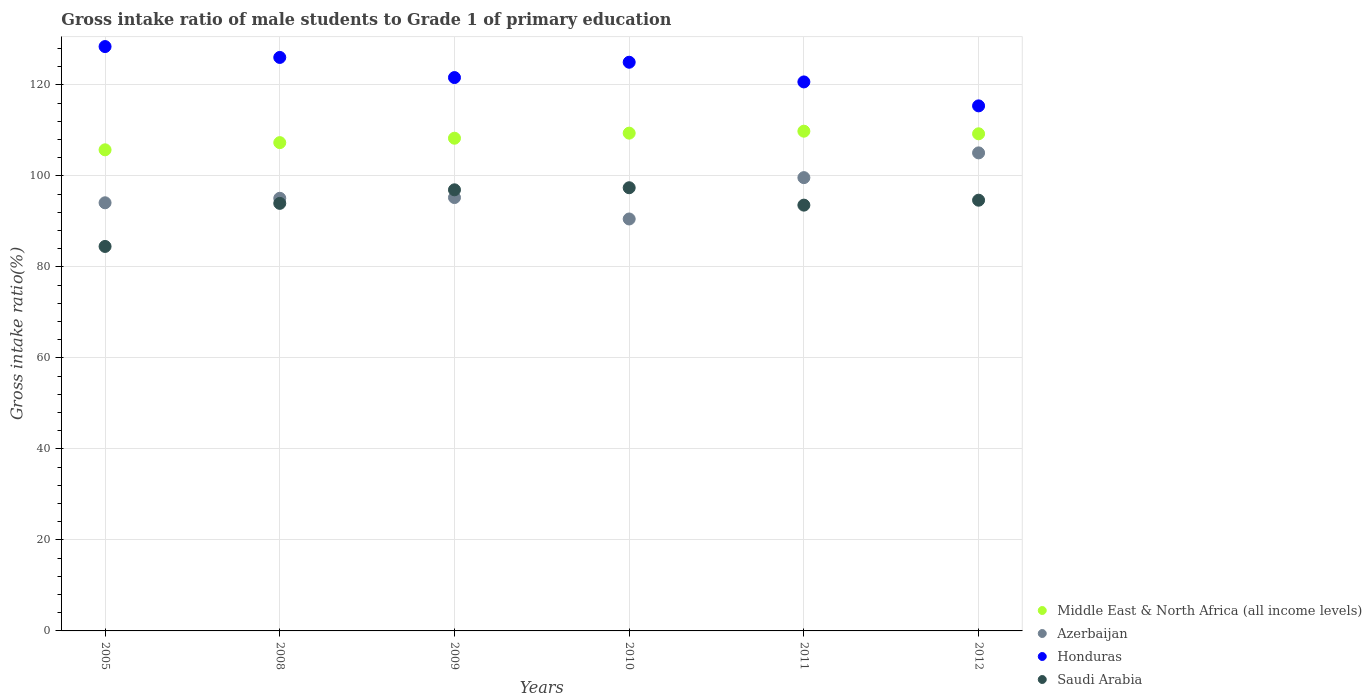What is the gross intake ratio in Middle East & North Africa (all income levels) in 2010?
Ensure brevity in your answer.  109.38. Across all years, what is the maximum gross intake ratio in Saudi Arabia?
Your answer should be compact. 97.39. Across all years, what is the minimum gross intake ratio in Honduras?
Offer a very short reply. 115.37. In which year was the gross intake ratio in Middle East & North Africa (all income levels) maximum?
Your answer should be compact. 2011. What is the total gross intake ratio in Azerbaijan in the graph?
Your answer should be very brief. 579.54. What is the difference between the gross intake ratio in Saudi Arabia in 2009 and that in 2011?
Ensure brevity in your answer.  3.36. What is the difference between the gross intake ratio in Azerbaijan in 2008 and the gross intake ratio in Middle East & North Africa (all income levels) in 2010?
Make the answer very short. -14.31. What is the average gross intake ratio in Honduras per year?
Your response must be concise. 122.83. In the year 2005, what is the difference between the gross intake ratio in Middle East & North Africa (all income levels) and gross intake ratio in Azerbaijan?
Make the answer very short. 11.64. In how many years, is the gross intake ratio in Azerbaijan greater than 40 %?
Make the answer very short. 6. What is the ratio of the gross intake ratio in Azerbaijan in 2008 to that in 2012?
Provide a succinct answer. 0.91. Is the gross intake ratio in Honduras in 2011 less than that in 2012?
Your answer should be compact. No. Is the difference between the gross intake ratio in Middle East & North Africa (all income levels) in 2005 and 2010 greater than the difference between the gross intake ratio in Azerbaijan in 2005 and 2010?
Your answer should be very brief. No. What is the difference between the highest and the second highest gross intake ratio in Honduras?
Offer a very short reply. 2.39. What is the difference between the highest and the lowest gross intake ratio in Honduras?
Provide a succinct answer. 13.03. Is it the case that in every year, the sum of the gross intake ratio in Azerbaijan and gross intake ratio in Honduras  is greater than the gross intake ratio in Saudi Arabia?
Your response must be concise. Yes. How many dotlines are there?
Offer a very short reply. 4. What is the title of the graph?
Keep it short and to the point. Gross intake ratio of male students to Grade 1 of primary education. What is the label or title of the X-axis?
Provide a short and direct response. Years. What is the label or title of the Y-axis?
Your answer should be very brief. Gross intake ratio(%). What is the Gross intake ratio(%) of Middle East & North Africa (all income levels) in 2005?
Keep it short and to the point. 105.72. What is the Gross intake ratio(%) in Azerbaijan in 2005?
Offer a terse response. 94.08. What is the Gross intake ratio(%) of Honduras in 2005?
Your answer should be compact. 128.41. What is the Gross intake ratio(%) of Saudi Arabia in 2005?
Offer a very short reply. 84.49. What is the Gross intake ratio(%) of Middle East & North Africa (all income levels) in 2008?
Offer a very short reply. 107.3. What is the Gross intake ratio(%) of Azerbaijan in 2008?
Provide a succinct answer. 95.07. What is the Gross intake ratio(%) in Honduras in 2008?
Provide a succinct answer. 126.02. What is the Gross intake ratio(%) in Saudi Arabia in 2008?
Your response must be concise. 93.95. What is the Gross intake ratio(%) of Middle East & North Africa (all income levels) in 2009?
Give a very brief answer. 108.27. What is the Gross intake ratio(%) in Azerbaijan in 2009?
Make the answer very short. 95.23. What is the Gross intake ratio(%) of Honduras in 2009?
Give a very brief answer. 121.59. What is the Gross intake ratio(%) of Saudi Arabia in 2009?
Your answer should be compact. 96.93. What is the Gross intake ratio(%) in Middle East & North Africa (all income levels) in 2010?
Offer a very short reply. 109.38. What is the Gross intake ratio(%) in Azerbaijan in 2010?
Ensure brevity in your answer.  90.52. What is the Gross intake ratio(%) in Honduras in 2010?
Ensure brevity in your answer.  124.96. What is the Gross intake ratio(%) in Saudi Arabia in 2010?
Your answer should be very brief. 97.39. What is the Gross intake ratio(%) of Middle East & North Africa (all income levels) in 2011?
Provide a short and direct response. 109.81. What is the Gross intake ratio(%) in Azerbaijan in 2011?
Your response must be concise. 99.61. What is the Gross intake ratio(%) in Honduras in 2011?
Your answer should be compact. 120.64. What is the Gross intake ratio(%) of Saudi Arabia in 2011?
Your answer should be very brief. 93.56. What is the Gross intake ratio(%) in Middle East & North Africa (all income levels) in 2012?
Your answer should be very brief. 109.24. What is the Gross intake ratio(%) of Azerbaijan in 2012?
Provide a short and direct response. 105.04. What is the Gross intake ratio(%) in Honduras in 2012?
Ensure brevity in your answer.  115.37. What is the Gross intake ratio(%) of Saudi Arabia in 2012?
Keep it short and to the point. 94.65. Across all years, what is the maximum Gross intake ratio(%) in Middle East & North Africa (all income levels)?
Your answer should be very brief. 109.81. Across all years, what is the maximum Gross intake ratio(%) in Azerbaijan?
Offer a very short reply. 105.04. Across all years, what is the maximum Gross intake ratio(%) of Honduras?
Ensure brevity in your answer.  128.41. Across all years, what is the maximum Gross intake ratio(%) in Saudi Arabia?
Provide a succinct answer. 97.39. Across all years, what is the minimum Gross intake ratio(%) in Middle East & North Africa (all income levels)?
Your answer should be very brief. 105.72. Across all years, what is the minimum Gross intake ratio(%) in Azerbaijan?
Make the answer very short. 90.52. Across all years, what is the minimum Gross intake ratio(%) in Honduras?
Your answer should be compact. 115.37. Across all years, what is the minimum Gross intake ratio(%) of Saudi Arabia?
Give a very brief answer. 84.49. What is the total Gross intake ratio(%) of Middle East & North Africa (all income levels) in the graph?
Make the answer very short. 649.71. What is the total Gross intake ratio(%) in Azerbaijan in the graph?
Your answer should be very brief. 579.54. What is the total Gross intake ratio(%) in Honduras in the graph?
Give a very brief answer. 736.99. What is the total Gross intake ratio(%) in Saudi Arabia in the graph?
Your answer should be compact. 560.96. What is the difference between the Gross intake ratio(%) of Middle East & North Africa (all income levels) in 2005 and that in 2008?
Give a very brief answer. -1.58. What is the difference between the Gross intake ratio(%) in Azerbaijan in 2005 and that in 2008?
Offer a very short reply. -0.99. What is the difference between the Gross intake ratio(%) in Honduras in 2005 and that in 2008?
Provide a short and direct response. 2.39. What is the difference between the Gross intake ratio(%) in Saudi Arabia in 2005 and that in 2008?
Ensure brevity in your answer.  -9.46. What is the difference between the Gross intake ratio(%) in Middle East & North Africa (all income levels) in 2005 and that in 2009?
Ensure brevity in your answer.  -2.55. What is the difference between the Gross intake ratio(%) in Azerbaijan in 2005 and that in 2009?
Your answer should be compact. -1.15. What is the difference between the Gross intake ratio(%) of Honduras in 2005 and that in 2009?
Make the answer very short. 6.81. What is the difference between the Gross intake ratio(%) in Saudi Arabia in 2005 and that in 2009?
Offer a very short reply. -12.44. What is the difference between the Gross intake ratio(%) of Middle East & North Africa (all income levels) in 2005 and that in 2010?
Your response must be concise. -3.66. What is the difference between the Gross intake ratio(%) of Azerbaijan in 2005 and that in 2010?
Provide a succinct answer. 3.56. What is the difference between the Gross intake ratio(%) in Honduras in 2005 and that in 2010?
Your answer should be compact. 3.44. What is the difference between the Gross intake ratio(%) in Saudi Arabia in 2005 and that in 2010?
Keep it short and to the point. -12.9. What is the difference between the Gross intake ratio(%) in Middle East & North Africa (all income levels) in 2005 and that in 2011?
Keep it short and to the point. -4.09. What is the difference between the Gross intake ratio(%) of Azerbaijan in 2005 and that in 2011?
Your response must be concise. -5.53. What is the difference between the Gross intake ratio(%) in Honduras in 2005 and that in 2011?
Keep it short and to the point. 7.77. What is the difference between the Gross intake ratio(%) in Saudi Arabia in 2005 and that in 2011?
Your answer should be very brief. -9.08. What is the difference between the Gross intake ratio(%) in Middle East & North Africa (all income levels) in 2005 and that in 2012?
Keep it short and to the point. -3.52. What is the difference between the Gross intake ratio(%) in Azerbaijan in 2005 and that in 2012?
Keep it short and to the point. -10.97. What is the difference between the Gross intake ratio(%) of Honduras in 2005 and that in 2012?
Make the answer very short. 13.03. What is the difference between the Gross intake ratio(%) in Saudi Arabia in 2005 and that in 2012?
Offer a terse response. -10.16. What is the difference between the Gross intake ratio(%) in Middle East & North Africa (all income levels) in 2008 and that in 2009?
Offer a terse response. -0.97. What is the difference between the Gross intake ratio(%) in Azerbaijan in 2008 and that in 2009?
Your answer should be compact. -0.16. What is the difference between the Gross intake ratio(%) in Honduras in 2008 and that in 2009?
Ensure brevity in your answer.  4.42. What is the difference between the Gross intake ratio(%) of Saudi Arabia in 2008 and that in 2009?
Your answer should be very brief. -2.98. What is the difference between the Gross intake ratio(%) in Middle East & North Africa (all income levels) in 2008 and that in 2010?
Make the answer very short. -2.08. What is the difference between the Gross intake ratio(%) in Azerbaijan in 2008 and that in 2010?
Your answer should be very brief. 4.55. What is the difference between the Gross intake ratio(%) in Honduras in 2008 and that in 2010?
Ensure brevity in your answer.  1.06. What is the difference between the Gross intake ratio(%) of Saudi Arabia in 2008 and that in 2010?
Keep it short and to the point. -3.44. What is the difference between the Gross intake ratio(%) of Middle East & North Africa (all income levels) in 2008 and that in 2011?
Make the answer very short. -2.51. What is the difference between the Gross intake ratio(%) in Azerbaijan in 2008 and that in 2011?
Keep it short and to the point. -4.54. What is the difference between the Gross intake ratio(%) in Honduras in 2008 and that in 2011?
Make the answer very short. 5.38. What is the difference between the Gross intake ratio(%) in Saudi Arabia in 2008 and that in 2011?
Your answer should be very brief. 0.39. What is the difference between the Gross intake ratio(%) of Middle East & North Africa (all income levels) in 2008 and that in 2012?
Provide a short and direct response. -1.94. What is the difference between the Gross intake ratio(%) in Azerbaijan in 2008 and that in 2012?
Provide a short and direct response. -9.98. What is the difference between the Gross intake ratio(%) of Honduras in 2008 and that in 2012?
Your answer should be very brief. 10.64. What is the difference between the Gross intake ratio(%) in Saudi Arabia in 2008 and that in 2012?
Provide a short and direct response. -0.7. What is the difference between the Gross intake ratio(%) in Middle East & North Africa (all income levels) in 2009 and that in 2010?
Your answer should be compact. -1.11. What is the difference between the Gross intake ratio(%) of Azerbaijan in 2009 and that in 2010?
Your answer should be very brief. 4.71. What is the difference between the Gross intake ratio(%) of Honduras in 2009 and that in 2010?
Keep it short and to the point. -3.37. What is the difference between the Gross intake ratio(%) in Saudi Arabia in 2009 and that in 2010?
Make the answer very short. -0.46. What is the difference between the Gross intake ratio(%) of Middle East & North Africa (all income levels) in 2009 and that in 2011?
Give a very brief answer. -1.54. What is the difference between the Gross intake ratio(%) in Azerbaijan in 2009 and that in 2011?
Provide a succinct answer. -4.38. What is the difference between the Gross intake ratio(%) of Honduras in 2009 and that in 2011?
Ensure brevity in your answer.  0.96. What is the difference between the Gross intake ratio(%) of Saudi Arabia in 2009 and that in 2011?
Give a very brief answer. 3.36. What is the difference between the Gross intake ratio(%) in Middle East & North Africa (all income levels) in 2009 and that in 2012?
Offer a terse response. -0.97. What is the difference between the Gross intake ratio(%) of Azerbaijan in 2009 and that in 2012?
Provide a short and direct response. -9.82. What is the difference between the Gross intake ratio(%) of Honduras in 2009 and that in 2012?
Offer a terse response. 6.22. What is the difference between the Gross intake ratio(%) in Saudi Arabia in 2009 and that in 2012?
Make the answer very short. 2.28. What is the difference between the Gross intake ratio(%) of Middle East & North Africa (all income levels) in 2010 and that in 2011?
Your answer should be compact. -0.43. What is the difference between the Gross intake ratio(%) in Azerbaijan in 2010 and that in 2011?
Provide a succinct answer. -9.09. What is the difference between the Gross intake ratio(%) in Honduras in 2010 and that in 2011?
Your answer should be very brief. 4.32. What is the difference between the Gross intake ratio(%) in Saudi Arabia in 2010 and that in 2011?
Your answer should be compact. 3.82. What is the difference between the Gross intake ratio(%) in Middle East & North Africa (all income levels) in 2010 and that in 2012?
Provide a short and direct response. 0.14. What is the difference between the Gross intake ratio(%) of Azerbaijan in 2010 and that in 2012?
Your answer should be compact. -14.52. What is the difference between the Gross intake ratio(%) in Honduras in 2010 and that in 2012?
Your response must be concise. 9.59. What is the difference between the Gross intake ratio(%) in Saudi Arabia in 2010 and that in 2012?
Provide a short and direct response. 2.74. What is the difference between the Gross intake ratio(%) in Middle East & North Africa (all income levels) in 2011 and that in 2012?
Provide a succinct answer. 0.57. What is the difference between the Gross intake ratio(%) of Azerbaijan in 2011 and that in 2012?
Keep it short and to the point. -5.44. What is the difference between the Gross intake ratio(%) of Honduras in 2011 and that in 2012?
Keep it short and to the point. 5.26. What is the difference between the Gross intake ratio(%) in Saudi Arabia in 2011 and that in 2012?
Make the answer very short. -1.08. What is the difference between the Gross intake ratio(%) in Middle East & North Africa (all income levels) in 2005 and the Gross intake ratio(%) in Azerbaijan in 2008?
Offer a very short reply. 10.65. What is the difference between the Gross intake ratio(%) of Middle East & North Africa (all income levels) in 2005 and the Gross intake ratio(%) of Honduras in 2008?
Offer a very short reply. -20.3. What is the difference between the Gross intake ratio(%) in Middle East & North Africa (all income levels) in 2005 and the Gross intake ratio(%) in Saudi Arabia in 2008?
Your answer should be compact. 11.77. What is the difference between the Gross intake ratio(%) in Azerbaijan in 2005 and the Gross intake ratio(%) in Honduras in 2008?
Your answer should be compact. -31.94. What is the difference between the Gross intake ratio(%) of Azerbaijan in 2005 and the Gross intake ratio(%) of Saudi Arabia in 2008?
Keep it short and to the point. 0.13. What is the difference between the Gross intake ratio(%) in Honduras in 2005 and the Gross intake ratio(%) in Saudi Arabia in 2008?
Provide a succinct answer. 34.46. What is the difference between the Gross intake ratio(%) of Middle East & North Africa (all income levels) in 2005 and the Gross intake ratio(%) of Azerbaijan in 2009?
Provide a succinct answer. 10.49. What is the difference between the Gross intake ratio(%) of Middle East & North Africa (all income levels) in 2005 and the Gross intake ratio(%) of Honduras in 2009?
Your answer should be compact. -15.88. What is the difference between the Gross intake ratio(%) in Middle East & North Africa (all income levels) in 2005 and the Gross intake ratio(%) in Saudi Arabia in 2009?
Make the answer very short. 8.79. What is the difference between the Gross intake ratio(%) in Azerbaijan in 2005 and the Gross intake ratio(%) in Honduras in 2009?
Make the answer very short. -27.52. What is the difference between the Gross intake ratio(%) in Azerbaijan in 2005 and the Gross intake ratio(%) in Saudi Arabia in 2009?
Your answer should be very brief. -2.85. What is the difference between the Gross intake ratio(%) of Honduras in 2005 and the Gross intake ratio(%) of Saudi Arabia in 2009?
Offer a very short reply. 31.48. What is the difference between the Gross intake ratio(%) of Middle East & North Africa (all income levels) in 2005 and the Gross intake ratio(%) of Azerbaijan in 2010?
Keep it short and to the point. 15.2. What is the difference between the Gross intake ratio(%) in Middle East & North Africa (all income levels) in 2005 and the Gross intake ratio(%) in Honduras in 2010?
Keep it short and to the point. -19.24. What is the difference between the Gross intake ratio(%) of Middle East & North Africa (all income levels) in 2005 and the Gross intake ratio(%) of Saudi Arabia in 2010?
Provide a short and direct response. 8.33. What is the difference between the Gross intake ratio(%) in Azerbaijan in 2005 and the Gross intake ratio(%) in Honduras in 2010?
Offer a terse response. -30.88. What is the difference between the Gross intake ratio(%) of Azerbaijan in 2005 and the Gross intake ratio(%) of Saudi Arabia in 2010?
Give a very brief answer. -3.31. What is the difference between the Gross intake ratio(%) of Honduras in 2005 and the Gross intake ratio(%) of Saudi Arabia in 2010?
Your answer should be compact. 31.02. What is the difference between the Gross intake ratio(%) in Middle East & North Africa (all income levels) in 2005 and the Gross intake ratio(%) in Azerbaijan in 2011?
Your response must be concise. 6.11. What is the difference between the Gross intake ratio(%) of Middle East & North Africa (all income levels) in 2005 and the Gross intake ratio(%) of Honduras in 2011?
Ensure brevity in your answer.  -14.92. What is the difference between the Gross intake ratio(%) of Middle East & North Africa (all income levels) in 2005 and the Gross intake ratio(%) of Saudi Arabia in 2011?
Offer a very short reply. 12.15. What is the difference between the Gross intake ratio(%) in Azerbaijan in 2005 and the Gross intake ratio(%) in Honduras in 2011?
Offer a terse response. -26.56. What is the difference between the Gross intake ratio(%) in Azerbaijan in 2005 and the Gross intake ratio(%) in Saudi Arabia in 2011?
Your answer should be compact. 0.51. What is the difference between the Gross intake ratio(%) of Honduras in 2005 and the Gross intake ratio(%) of Saudi Arabia in 2011?
Make the answer very short. 34.84. What is the difference between the Gross intake ratio(%) in Middle East & North Africa (all income levels) in 2005 and the Gross intake ratio(%) in Azerbaijan in 2012?
Provide a short and direct response. 0.67. What is the difference between the Gross intake ratio(%) in Middle East & North Africa (all income levels) in 2005 and the Gross intake ratio(%) in Honduras in 2012?
Make the answer very short. -9.66. What is the difference between the Gross intake ratio(%) in Middle East & North Africa (all income levels) in 2005 and the Gross intake ratio(%) in Saudi Arabia in 2012?
Your response must be concise. 11.07. What is the difference between the Gross intake ratio(%) of Azerbaijan in 2005 and the Gross intake ratio(%) of Honduras in 2012?
Your answer should be compact. -21.3. What is the difference between the Gross intake ratio(%) in Azerbaijan in 2005 and the Gross intake ratio(%) in Saudi Arabia in 2012?
Your answer should be very brief. -0.57. What is the difference between the Gross intake ratio(%) of Honduras in 2005 and the Gross intake ratio(%) of Saudi Arabia in 2012?
Provide a short and direct response. 33.76. What is the difference between the Gross intake ratio(%) in Middle East & North Africa (all income levels) in 2008 and the Gross intake ratio(%) in Azerbaijan in 2009?
Your answer should be very brief. 12.07. What is the difference between the Gross intake ratio(%) in Middle East & North Africa (all income levels) in 2008 and the Gross intake ratio(%) in Honduras in 2009?
Ensure brevity in your answer.  -14.3. What is the difference between the Gross intake ratio(%) of Middle East & North Africa (all income levels) in 2008 and the Gross intake ratio(%) of Saudi Arabia in 2009?
Keep it short and to the point. 10.37. What is the difference between the Gross intake ratio(%) of Azerbaijan in 2008 and the Gross intake ratio(%) of Honduras in 2009?
Offer a very short reply. -26.53. What is the difference between the Gross intake ratio(%) in Azerbaijan in 2008 and the Gross intake ratio(%) in Saudi Arabia in 2009?
Your response must be concise. -1.86. What is the difference between the Gross intake ratio(%) of Honduras in 2008 and the Gross intake ratio(%) of Saudi Arabia in 2009?
Your answer should be very brief. 29.09. What is the difference between the Gross intake ratio(%) in Middle East & North Africa (all income levels) in 2008 and the Gross intake ratio(%) in Azerbaijan in 2010?
Make the answer very short. 16.78. What is the difference between the Gross intake ratio(%) in Middle East & North Africa (all income levels) in 2008 and the Gross intake ratio(%) in Honduras in 2010?
Your response must be concise. -17.66. What is the difference between the Gross intake ratio(%) in Middle East & North Africa (all income levels) in 2008 and the Gross intake ratio(%) in Saudi Arabia in 2010?
Give a very brief answer. 9.91. What is the difference between the Gross intake ratio(%) in Azerbaijan in 2008 and the Gross intake ratio(%) in Honduras in 2010?
Make the answer very short. -29.89. What is the difference between the Gross intake ratio(%) in Azerbaijan in 2008 and the Gross intake ratio(%) in Saudi Arabia in 2010?
Ensure brevity in your answer.  -2.32. What is the difference between the Gross intake ratio(%) in Honduras in 2008 and the Gross intake ratio(%) in Saudi Arabia in 2010?
Give a very brief answer. 28.63. What is the difference between the Gross intake ratio(%) of Middle East & North Africa (all income levels) in 2008 and the Gross intake ratio(%) of Azerbaijan in 2011?
Ensure brevity in your answer.  7.69. What is the difference between the Gross intake ratio(%) of Middle East & North Africa (all income levels) in 2008 and the Gross intake ratio(%) of Honduras in 2011?
Your response must be concise. -13.34. What is the difference between the Gross intake ratio(%) of Middle East & North Africa (all income levels) in 2008 and the Gross intake ratio(%) of Saudi Arabia in 2011?
Your response must be concise. 13.73. What is the difference between the Gross intake ratio(%) in Azerbaijan in 2008 and the Gross intake ratio(%) in Honduras in 2011?
Give a very brief answer. -25.57. What is the difference between the Gross intake ratio(%) in Azerbaijan in 2008 and the Gross intake ratio(%) in Saudi Arabia in 2011?
Keep it short and to the point. 1.5. What is the difference between the Gross intake ratio(%) in Honduras in 2008 and the Gross intake ratio(%) in Saudi Arabia in 2011?
Offer a very short reply. 32.45. What is the difference between the Gross intake ratio(%) of Middle East & North Africa (all income levels) in 2008 and the Gross intake ratio(%) of Azerbaijan in 2012?
Offer a terse response. 2.25. What is the difference between the Gross intake ratio(%) of Middle East & North Africa (all income levels) in 2008 and the Gross intake ratio(%) of Honduras in 2012?
Your answer should be very brief. -8.08. What is the difference between the Gross intake ratio(%) in Middle East & North Africa (all income levels) in 2008 and the Gross intake ratio(%) in Saudi Arabia in 2012?
Keep it short and to the point. 12.65. What is the difference between the Gross intake ratio(%) of Azerbaijan in 2008 and the Gross intake ratio(%) of Honduras in 2012?
Your answer should be very brief. -20.31. What is the difference between the Gross intake ratio(%) in Azerbaijan in 2008 and the Gross intake ratio(%) in Saudi Arabia in 2012?
Make the answer very short. 0.42. What is the difference between the Gross intake ratio(%) of Honduras in 2008 and the Gross intake ratio(%) of Saudi Arabia in 2012?
Provide a short and direct response. 31.37. What is the difference between the Gross intake ratio(%) in Middle East & North Africa (all income levels) in 2009 and the Gross intake ratio(%) in Azerbaijan in 2010?
Keep it short and to the point. 17.75. What is the difference between the Gross intake ratio(%) in Middle East & North Africa (all income levels) in 2009 and the Gross intake ratio(%) in Honduras in 2010?
Make the answer very short. -16.69. What is the difference between the Gross intake ratio(%) in Middle East & North Africa (all income levels) in 2009 and the Gross intake ratio(%) in Saudi Arabia in 2010?
Provide a short and direct response. 10.88. What is the difference between the Gross intake ratio(%) of Azerbaijan in 2009 and the Gross intake ratio(%) of Honduras in 2010?
Offer a very short reply. -29.73. What is the difference between the Gross intake ratio(%) in Azerbaijan in 2009 and the Gross intake ratio(%) in Saudi Arabia in 2010?
Your answer should be very brief. -2.16. What is the difference between the Gross intake ratio(%) in Honduras in 2009 and the Gross intake ratio(%) in Saudi Arabia in 2010?
Offer a terse response. 24.21. What is the difference between the Gross intake ratio(%) in Middle East & North Africa (all income levels) in 2009 and the Gross intake ratio(%) in Azerbaijan in 2011?
Your response must be concise. 8.66. What is the difference between the Gross intake ratio(%) in Middle East & North Africa (all income levels) in 2009 and the Gross intake ratio(%) in Honduras in 2011?
Provide a succinct answer. -12.37. What is the difference between the Gross intake ratio(%) in Middle East & North Africa (all income levels) in 2009 and the Gross intake ratio(%) in Saudi Arabia in 2011?
Your answer should be very brief. 14.7. What is the difference between the Gross intake ratio(%) in Azerbaijan in 2009 and the Gross intake ratio(%) in Honduras in 2011?
Your answer should be compact. -25.41. What is the difference between the Gross intake ratio(%) of Azerbaijan in 2009 and the Gross intake ratio(%) of Saudi Arabia in 2011?
Provide a succinct answer. 1.67. What is the difference between the Gross intake ratio(%) in Honduras in 2009 and the Gross intake ratio(%) in Saudi Arabia in 2011?
Provide a succinct answer. 28.03. What is the difference between the Gross intake ratio(%) in Middle East & North Africa (all income levels) in 2009 and the Gross intake ratio(%) in Azerbaijan in 2012?
Provide a short and direct response. 3.22. What is the difference between the Gross intake ratio(%) in Middle East & North Africa (all income levels) in 2009 and the Gross intake ratio(%) in Honduras in 2012?
Offer a terse response. -7.11. What is the difference between the Gross intake ratio(%) in Middle East & North Africa (all income levels) in 2009 and the Gross intake ratio(%) in Saudi Arabia in 2012?
Offer a very short reply. 13.62. What is the difference between the Gross intake ratio(%) in Azerbaijan in 2009 and the Gross intake ratio(%) in Honduras in 2012?
Your answer should be very brief. -20.14. What is the difference between the Gross intake ratio(%) of Azerbaijan in 2009 and the Gross intake ratio(%) of Saudi Arabia in 2012?
Keep it short and to the point. 0.58. What is the difference between the Gross intake ratio(%) in Honduras in 2009 and the Gross intake ratio(%) in Saudi Arabia in 2012?
Provide a short and direct response. 26.95. What is the difference between the Gross intake ratio(%) of Middle East & North Africa (all income levels) in 2010 and the Gross intake ratio(%) of Azerbaijan in 2011?
Offer a very short reply. 9.77. What is the difference between the Gross intake ratio(%) in Middle East & North Africa (all income levels) in 2010 and the Gross intake ratio(%) in Honduras in 2011?
Your answer should be very brief. -11.26. What is the difference between the Gross intake ratio(%) in Middle East & North Africa (all income levels) in 2010 and the Gross intake ratio(%) in Saudi Arabia in 2011?
Make the answer very short. 15.82. What is the difference between the Gross intake ratio(%) of Azerbaijan in 2010 and the Gross intake ratio(%) of Honduras in 2011?
Offer a very short reply. -30.12. What is the difference between the Gross intake ratio(%) of Azerbaijan in 2010 and the Gross intake ratio(%) of Saudi Arabia in 2011?
Give a very brief answer. -3.04. What is the difference between the Gross intake ratio(%) of Honduras in 2010 and the Gross intake ratio(%) of Saudi Arabia in 2011?
Your response must be concise. 31.4. What is the difference between the Gross intake ratio(%) in Middle East & North Africa (all income levels) in 2010 and the Gross intake ratio(%) in Azerbaijan in 2012?
Your answer should be very brief. 4.34. What is the difference between the Gross intake ratio(%) of Middle East & North Africa (all income levels) in 2010 and the Gross intake ratio(%) of Honduras in 2012?
Offer a terse response. -5.99. What is the difference between the Gross intake ratio(%) in Middle East & North Africa (all income levels) in 2010 and the Gross intake ratio(%) in Saudi Arabia in 2012?
Give a very brief answer. 14.73. What is the difference between the Gross intake ratio(%) in Azerbaijan in 2010 and the Gross intake ratio(%) in Honduras in 2012?
Your answer should be very brief. -24.85. What is the difference between the Gross intake ratio(%) of Azerbaijan in 2010 and the Gross intake ratio(%) of Saudi Arabia in 2012?
Give a very brief answer. -4.13. What is the difference between the Gross intake ratio(%) of Honduras in 2010 and the Gross intake ratio(%) of Saudi Arabia in 2012?
Offer a terse response. 30.31. What is the difference between the Gross intake ratio(%) of Middle East & North Africa (all income levels) in 2011 and the Gross intake ratio(%) of Azerbaijan in 2012?
Your answer should be compact. 4.77. What is the difference between the Gross intake ratio(%) of Middle East & North Africa (all income levels) in 2011 and the Gross intake ratio(%) of Honduras in 2012?
Keep it short and to the point. -5.56. What is the difference between the Gross intake ratio(%) in Middle East & North Africa (all income levels) in 2011 and the Gross intake ratio(%) in Saudi Arabia in 2012?
Offer a terse response. 15.16. What is the difference between the Gross intake ratio(%) in Azerbaijan in 2011 and the Gross intake ratio(%) in Honduras in 2012?
Keep it short and to the point. -15.77. What is the difference between the Gross intake ratio(%) in Azerbaijan in 2011 and the Gross intake ratio(%) in Saudi Arabia in 2012?
Your answer should be very brief. 4.96. What is the difference between the Gross intake ratio(%) of Honduras in 2011 and the Gross intake ratio(%) of Saudi Arabia in 2012?
Give a very brief answer. 25.99. What is the average Gross intake ratio(%) of Middle East & North Africa (all income levels) per year?
Your answer should be very brief. 108.29. What is the average Gross intake ratio(%) of Azerbaijan per year?
Make the answer very short. 96.59. What is the average Gross intake ratio(%) of Honduras per year?
Give a very brief answer. 122.83. What is the average Gross intake ratio(%) in Saudi Arabia per year?
Ensure brevity in your answer.  93.49. In the year 2005, what is the difference between the Gross intake ratio(%) in Middle East & North Africa (all income levels) and Gross intake ratio(%) in Azerbaijan?
Make the answer very short. 11.64. In the year 2005, what is the difference between the Gross intake ratio(%) of Middle East & North Africa (all income levels) and Gross intake ratio(%) of Honduras?
Provide a short and direct response. -22.69. In the year 2005, what is the difference between the Gross intake ratio(%) in Middle East & North Africa (all income levels) and Gross intake ratio(%) in Saudi Arabia?
Ensure brevity in your answer.  21.23. In the year 2005, what is the difference between the Gross intake ratio(%) of Azerbaijan and Gross intake ratio(%) of Honduras?
Keep it short and to the point. -34.33. In the year 2005, what is the difference between the Gross intake ratio(%) of Azerbaijan and Gross intake ratio(%) of Saudi Arabia?
Offer a very short reply. 9.59. In the year 2005, what is the difference between the Gross intake ratio(%) in Honduras and Gross intake ratio(%) in Saudi Arabia?
Ensure brevity in your answer.  43.92. In the year 2008, what is the difference between the Gross intake ratio(%) in Middle East & North Africa (all income levels) and Gross intake ratio(%) in Azerbaijan?
Make the answer very short. 12.23. In the year 2008, what is the difference between the Gross intake ratio(%) in Middle East & North Africa (all income levels) and Gross intake ratio(%) in Honduras?
Keep it short and to the point. -18.72. In the year 2008, what is the difference between the Gross intake ratio(%) of Middle East & North Africa (all income levels) and Gross intake ratio(%) of Saudi Arabia?
Your response must be concise. 13.35. In the year 2008, what is the difference between the Gross intake ratio(%) in Azerbaijan and Gross intake ratio(%) in Honduras?
Ensure brevity in your answer.  -30.95. In the year 2008, what is the difference between the Gross intake ratio(%) of Azerbaijan and Gross intake ratio(%) of Saudi Arabia?
Make the answer very short. 1.12. In the year 2008, what is the difference between the Gross intake ratio(%) in Honduras and Gross intake ratio(%) in Saudi Arabia?
Your answer should be very brief. 32.07. In the year 2009, what is the difference between the Gross intake ratio(%) in Middle East & North Africa (all income levels) and Gross intake ratio(%) in Azerbaijan?
Offer a terse response. 13.04. In the year 2009, what is the difference between the Gross intake ratio(%) in Middle East & North Africa (all income levels) and Gross intake ratio(%) in Honduras?
Provide a short and direct response. -13.33. In the year 2009, what is the difference between the Gross intake ratio(%) of Middle East & North Africa (all income levels) and Gross intake ratio(%) of Saudi Arabia?
Your answer should be compact. 11.34. In the year 2009, what is the difference between the Gross intake ratio(%) of Azerbaijan and Gross intake ratio(%) of Honduras?
Offer a terse response. -26.36. In the year 2009, what is the difference between the Gross intake ratio(%) of Azerbaijan and Gross intake ratio(%) of Saudi Arabia?
Provide a succinct answer. -1.7. In the year 2009, what is the difference between the Gross intake ratio(%) of Honduras and Gross intake ratio(%) of Saudi Arabia?
Give a very brief answer. 24.67. In the year 2010, what is the difference between the Gross intake ratio(%) of Middle East & North Africa (all income levels) and Gross intake ratio(%) of Azerbaijan?
Provide a succinct answer. 18.86. In the year 2010, what is the difference between the Gross intake ratio(%) of Middle East & North Africa (all income levels) and Gross intake ratio(%) of Honduras?
Offer a very short reply. -15.58. In the year 2010, what is the difference between the Gross intake ratio(%) of Middle East & North Africa (all income levels) and Gross intake ratio(%) of Saudi Arabia?
Make the answer very short. 11.99. In the year 2010, what is the difference between the Gross intake ratio(%) in Azerbaijan and Gross intake ratio(%) in Honduras?
Keep it short and to the point. -34.44. In the year 2010, what is the difference between the Gross intake ratio(%) of Azerbaijan and Gross intake ratio(%) of Saudi Arabia?
Make the answer very short. -6.87. In the year 2010, what is the difference between the Gross intake ratio(%) in Honduras and Gross intake ratio(%) in Saudi Arabia?
Your response must be concise. 27.58. In the year 2011, what is the difference between the Gross intake ratio(%) in Middle East & North Africa (all income levels) and Gross intake ratio(%) in Azerbaijan?
Ensure brevity in your answer.  10.21. In the year 2011, what is the difference between the Gross intake ratio(%) of Middle East & North Africa (all income levels) and Gross intake ratio(%) of Honduras?
Provide a succinct answer. -10.83. In the year 2011, what is the difference between the Gross intake ratio(%) of Middle East & North Africa (all income levels) and Gross intake ratio(%) of Saudi Arabia?
Keep it short and to the point. 16.25. In the year 2011, what is the difference between the Gross intake ratio(%) in Azerbaijan and Gross intake ratio(%) in Honduras?
Give a very brief answer. -21.03. In the year 2011, what is the difference between the Gross intake ratio(%) of Azerbaijan and Gross intake ratio(%) of Saudi Arabia?
Offer a very short reply. 6.04. In the year 2011, what is the difference between the Gross intake ratio(%) in Honduras and Gross intake ratio(%) in Saudi Arabia?
Provide a succinct answer. 27.07. In the year 2012, what is the difference between the Gross intake ratio(%) in Middle East & North Africa (all income levels) and Gross intake ratio(%) in Azerbaijan?
Your response must be concise. 4.2. In the year 2012, what is the difference between the Gross intake ratio(%) in Middle East & North Africa (all income levels) and Gross intake ratio(%) in Honduras?
Your response must be concise. -6.13. In the year 2012, what is the difference between the Gross intake ratio(%) in Middle East & North Africa (all income levels) and Gross intake ratio(%) in Saudi Arabia?
Your response must be concise. 14.59. In the year 2012, what is the difference between the Gross intake ratio(%) in Azerbaijan and Gross intake ratio(%) in Honduras?
Your answer should be compact. -10.33. In the year 2012, what is the difference between the Gross intake ratio(%) in Azerbaijan and Gross intake ratio(%) in Saudi Arabia?
Provide a short and direct response. 10.4. In the year 2012, what is the difference between the Gross intake ratio(%) in Honduras and Gross intake ratio(%) in Saudi Arabia?
Your answer should be compact. 20.73. What is the ratio of the Gross intake ratio(%) of Honduras in 2005 to that in 2008?
Keep it short and to the point. 1.02. What is the ratio of the Gross intake ratio(%) of Saudi Arabia in 2005 to that in 2008?
Make the answer very short. 0.9. What is the ratio of the Gross intake ratio(%) in Middle East & North Africa (all income levels) in 2005 to that in 2009?
Give a very brief answer. 0.98. What is the ratio of the Gross intake ratio(%) in Azerbaijan in 2005 to that in 2009?
Provide a short and direct response. 0.99. What is the ratio of the Gross intake ratio(%) of Honduras in 2005 to that in 2009?
Provide a short and direct response. 1.06. What is the ratio of the Gross intake ratio(%) of Saudi Arabia in 2005 to that in 2009?
Your response must be concise. 0.87. What is the ratio of the Gross intake ratio(%) in Middle East & North Africa (all income levels) in 2005 to that in 2010?
Provide a short and direct response. 0.97. What is the ratio of the Gross intake ratio(%) in Azerbaijan in 2005 to that in 2010?
Give a very brief answer. 1.04. What is the ratio of the Gross intake ratio(%) in Honduras in 2005 to that in 2010?
Provide a short and direct response. 1.03. What is the ratio of the Gross intake ratio(%) of Saudi Arabia in 2005 to that in 2010?
Ensure brevity in your answer.  0.87. What is the ratio of the Gross intake ratio(%) in Middle East & North Africa (all income levels) in 2005 to that in 2011?
Keep it short and to the point. 0.96. What is the ratio of the Gross intake ratio(%) in Azerbaijan in 2005 to that in 2011?
Keep it short and to the point. 0.94. What is the ratio of the Gross intake ratio(%) of Honduras in 2005 to that in 2011?
Offer a very short reply. 1.06. What is the ratio of the Gross intake ratio(%) of Saudi Arabia in 2005 to that in 2011?
Give a very brief answer. 0.9. What is the ratio of the Gross intake ratio(%) in Middle East & North Africa (all income levels) in 2005 to that in 2012?
Give a very brief answer. 0.97. What is the ratio of the Gross intake ratio(%) in Azerbaijan in 2005 to that in 2012?
Your response must be concise. 0.9. What is the ratio of the Gross intake ratio(%) in Honduras in 2005 to that in 2012?
Ensure brevity in your answer.  1.11. What is the ratio of the Gross intake ratio(%) of Saudi Arabia in 2005 to that in 2012?
Offer a terse response. 0.89. What is the ratio of the Gross intake ratio(%) in Azerbaijan in 2008 to that in 2009?
Offer a terse response. 1. What is the ratio of the Gross intake ratio(%) of Honduras in 2008 to that in 2009?
Make the answer very short. 1.04. What is the ratio of the Gross intake ratio(%) of Saudi Arabia in 2008 to that in 2009?
Your answer should be compact. 0.97. What is the ratio of the Gross intake ratio(%) in Middle East & North Africa (all income levels) in 2008 to that in 2010?
Offer a very short reply. 0.98. What is the ratio of the Gross intake ratio(%) of Azerbaijan in 2008 to that in 2010?
Offer a terse response. 1.05. What is the ratio of the Gross intake ratio(%) of Honduras in 2008 to that in 2010?
Make the answer very short. 1.01. What is the ratio of the Gross intake ratio(%) in Saudi Arabia in 2008 to that in 2010?
Give a very brief answer. 0.96. What is the ratio of the Gross intake ratio(%) in Middle East & North Africa (all income levels) in 2008 to that in 2011?
Make the answer very short. 0.98. What is the ratio of the Gross intake ratio(%) in Azerbaijan in 2008 to that in 2011?
Your answer should be compact. 0.95. What is the ratio of the Gross intake ratio(%) of Honduras in 2008 to that in 2011?
Offer a terse response. 1.04. What is the ratio of the Gross intake ratio(%) in Saudi Arabia in 2008 to that in 2011?
Ensure brevity in your answer.  1. What is the ratio of the Gross intake ratio(%) of Middle East & North Africa (all income levels) in 2008 to that in 2012?
Offer a terse response. 0.98. What is the ratio of the Gross intake ratio(%) of Azerbaijan in 2008 to that in 2012?
Provide a short and direct response. 0.91. What is the ratio of the Gross intake ratio(%) in Honduras in 2008 to that in 2012?
Offer a very short reply. 1.09. What is the ratio of the Gross intake ratio(%) in Saudi Arabia in 2008 to that in 2012?
Your answer should be very brief. 0.99. What is the ratio of the Gross intake ratio(%) in Middle East & North Africa (all income levels) in 2009 to that in 2010?
Your response must be concise. 0.99. What is the ratio of the Gross intake ratio(%) of Azerbaijan in 2009 to that in 2010?
Your answer should be compact. 1.05. What is the ratio of the Gross intake ratio(%) in Honduras in 2009 to that in 2010?
Provide a short and direct response. 0.97. What is the ratio of the Gross intake ratio(%) of Middle East & North Africa (all income levels) in 2009 to that in 2011?
Offer a terse response. 0.99. What is the ratio of the Gross intake ratio(%) in Azerbaijan in 2009 to that in 2011?
Provide a short and direct response. 0.96. What is the ratio of the Gross intake ratio(%) in Honduras in 2009 to that in 2011?
Keep it short and to the point. 1.01. What is the ratio of the Gross intake ratio(%) in Saudi Arabia in 2009 to that in 2011?
Make the answer very short. 1.04. What is the ratio of the Gross intake ratio(%) of Azerbaijan in 2009 to that in 2012?
Offer a very short reply. 0.91. What is the ratio of the Gross intake ratio(%) in Honduras in 2009 to that in 2012?
Your answer should be compact. 1.05. What is the ratio of the Gross intake ratio(%) of Saudi Arabia in 2009 to that in 2012?
Give a very brief answer. 1.02. What is the ratio of the Gross intake ratio(%) of Middle East & North Africa (all income levels) in 2010 to that in 2011?
Provide a succinct answer. 1. What is the ratio of the Gross intake ratio(%) in Azerbaijan in 2010 to that in 2011?
Your response must be concise. 0.91. What is the ratio of the Gross intake ratio(%) of Honduras in 2010 to that in 2011?
Your answer should be very brief. 1.04. What is the ratio of the Gross intake ratio(%) of Saudi Arabia in 2010 to that in 2011?
Provide a short and direct response. 1.04. What is the ratio of the Gross intake ratio(%) in Azerbaijan in 2010 to that in 2012?
Provide a succinct answer. 0.86. What is the ratio of the Gross intake ratio(%) in Honduras in 2010 to that in 2012?
Provide a succinct answer. 1.08. What is the ratio of the Gross intake ratio(%) in Saudi Arabia in 2010 to that in 2012?
Keep it short and to the point. 1.03. What is the ratio of the Gross intake ratio(%) of Middle East & North Africa (all income levels) in 2011 to that in 2012?
Keep it short and to the point. 1.01. What is the ratio of the Gross intake ratio(%) in Azerbaijan in 2011 to that in 2012?
Offer a very short reply. 0.95. What is the ratio of the Gross intake ratio(%) in Honduras in 2011 to that in 2012?
Keep it short and to the point. 1.05. What is the ratio of the Gross intake ratio(%) in Saudi Arabia in 2011 to that in 2012?
Offer a very short reply. 0.99. What is the difference between the highest and the second highest Gross intake ratio(%) in Middle East & North Africa (all income levels)?
Provide a succinct answer. 0.43. What is the difference between the highest and the second highest Gross intake ratio(%) of Azerbaijan?
Provide a succinct answer. 5.44. What is the difference between the highest and the second highest Gross intake ratio(%) of Honduras?
Give a very brief answer. 2.39. What is the difference between the highest and the second highest Gross intake ratio(%) in Saudi Arabia?
Ensure brevity in your answer.  0.46. What is the difference between the highest and the lowest Gross intake ratio(%) of Middle East & North Africa (all income levels)?
Offer a very short reply. 4.09. What is the difference between the highest and the lowest Gross intake ratio(%) of Azerbaijan?
Make the answer very short. 14.52. What is the difference between the highest and the lowest Gross intake ratio(%) of Honduras?
Offer a very short reply. 13.03. What is the difference between the highest and the lowest Gross intake ratio(%) in Saudi Arabia?
Your response must be concise. 12.9. 